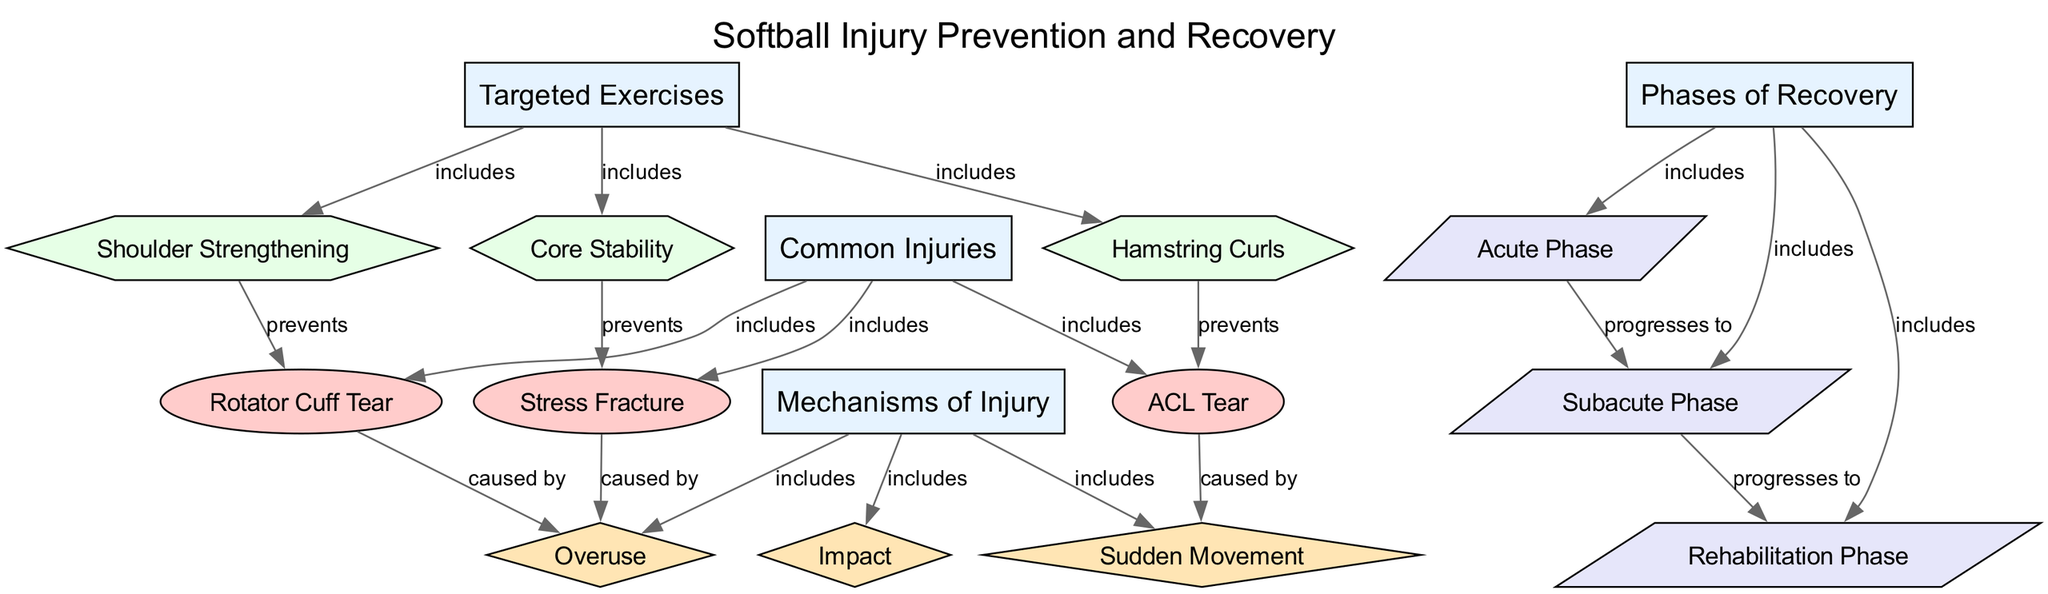What are the common injuries listed in the diagram? The nodes connected to the "Common Injuries" category include "Rotator Cuff Tear," "ACL Tear," and "Stress Fracture." By examining the edges that connect the category node to the injury nodes, we can determine the specific injuries that are listed.
Answer: Rotator Cuff Tear, ACL Tear, Stress Fracture How many mechanisms of injury are included in the diagram? The "Mechanisms of Injury" node has three connected nodes: "Overuse," "Impact," and "Sudden Movement." Thus, by counting the edges linking to the mechanisms node, we find that there are three mechanisms of injury.
Answer: 3 What exercise is associated with preventing a Rotator Cuff Tear? The edge connecting "Shoulder Strengthening" to "Rotator Cuff Tear" indicates that this exercise is specifically linked to the prevention of a Rotator Cuff Tear, as shown in the diagram.
Answer: Shoulder Strengthening Which injury is caused by Sudden Movement? The diagram shows an edge from "ACL Tear" to "Sudden Movement," indicating that this injury is specifically caused by this mechanism of injury. By following the relationship in the diagram, we can identify that the ACL Tear is associated with this mechanism.
Answer: ACL Tear What progression occurs after the Acute Phase in recovery? The connection from "Acute Phase" to "Subacute Phase" indicates that the recovery process moves from the Acute Phase to the Subacute Phase. Thus, we can see that the progression in recovery is from the Acute Phase directly to the next phase indicated.
Answer: Subacute Phase 